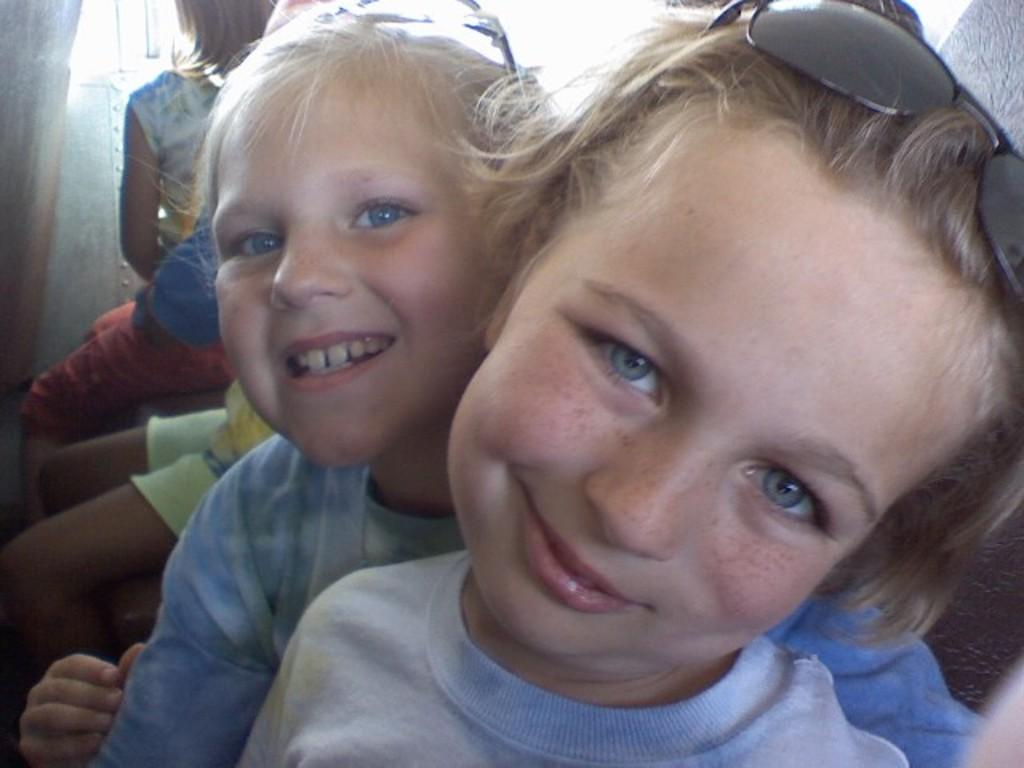Who is present in the image? There are children in the image. What is the children's emotional state in the image? The children are smiling in the image. What can be seen on top of the children's heads? There are spectacles visible on the top of the children's heads. What type of suit is the child wearing in the image? There is no suit visible in the image; the children are not wearing any clothing mentioned in the facts. 